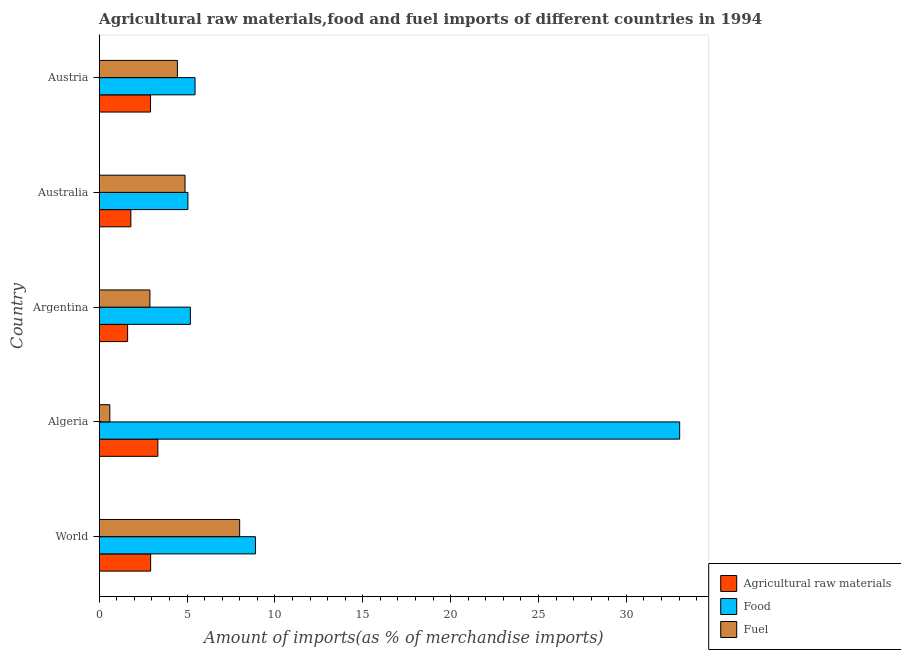How many different coloured bars are there?
Ensure brevity in your answer.  3. Are the number of bars per tick equal to the number of legend labels?
Provide a short and direct response. Yes. Are the number of bars on each tick of the Y-axis equal?
Make the answer very short. Yes. How many bars are there on the 2nd tick from the top?
Your response must be concise. 3. What is the percentage of fuel imports in Austria?
Your answer should be very brief. 4.45. Across all countries, what is the maximum percentage of food imports?
Give a very brief answer. 33.04. Across all countries, what is the minimum percentage of fuel imports?
Your answer should be very brief. 0.6. In which country was the percentage of raw materials imports maximum?
Offer a very short reply. Algeria. What is the total percentage of fuel imports in the graph?
Your answer should be very brief. 20.82. What is the difference between the percentage of raw materials imports in Algeria and that in Austria?
Offer a terse response. 0.42. What is the difference between the percentage of food imports in Argentina and the percentage of fuel imports in Australia?
Your answer should be compact. 0.31. What is the average percentage of fuel imports per country?
Make the answer very short. 4.16. What is the difference between the percentage of food imports and percentage of raw materials imports in Algeria?
Provide a succinct answer. 29.7. In how many countries, is the percentage of raw materials imports greater than 23 %?
Your answer should be compact. 0. What is the ratio of the percentage of food imports in Algeria to that in Austria?
Your response must be concise. 6.06. Is the percentage of raw materials imports in Australia less than that in World?
Provide a succinct answer. Yes. What is the difference between the highest and the second highest percentage of raw materials imports?
Ensure brevity in your answer.  0.41. What is the difference between the highest and the lowest percentage of fuel imports?
Your answer should be very brief. 7.39. What does the 3rd bar from the top in Argentina represents?
Give a very brief answer. Agricultural raw materials. What does the 3rd bar from the bottom in Argentina represents?
Provide a succinct answer. Fuel. Is it the case that in every country, the sum of the percentage of raw materials imports and percentage of food imports is greater than the percentage of fuel imports?
Ensure brevity in your answer.  Yes. How many bars are there?
Offer a terse response. 15. How many countries are there in the graph?
Give a very brief answer. 5. What is the difference between two consecutive major ticks on the X-axis?
Give a very brief answer. 5. Does the graph contain grids?
Make the answer very short. No. What is the title of the graph?
Ensure brevity in your answer.  Agricultural raw materials,food and fuel imports of different countries in 1994. What is the label or title of the X-axis?
Provide a succinct answer. Amount of imports(as % of merchandise imports). What is the Amount of imports(as % of merchandise imports) of Agricultural raw materials in World?
Keep it short and to the point. 2.93. What is the Amount of imports(as % of merchandise imports) of Food in World?
Offer a terse response. 8.89. What is the Amount of imports(as % of merchandise imports) of Fuel in World?
Provide a succinct answer. 7.99. What is the Amount of imports(as % of merchandise imports) of Agricultural raw materials in Algeria?
Your answer should be compact. 3.34. What is the Amount of imports(as % of merchandise imports) of Food in Algeria?
Make the answer very short. 33.04. What is the Amount of imports(as % of merchandise imports) of Fuel in Algeria?
Make the answer very short. 0.6. What is the Amount of imports(as % of merchandise imports) of Agricultural raw materials in Argentina?
Keep it short and to the point. 1.62. What is the Amount of imports(as % of merchandise imports) of Food in Argentina?
Give a very brief answer. 5.19. What is the Amount of imports(as % of merchandise imports) in Fuel in Argentina?
Provide a succinct answer. 2.88. What is the Amount of imports(as % of merchandise imports) of Agricultural raw materials in Australia?
Make the answer very short. 1.8. What is the Amount of imports(as % of merchandise imports) of Food in Australia?
Offer a terse response. 5.05. What is the Amount of imports(as % of merchandise imports) of Fuel in Australia?
Offer a very short reply. 4.88. What is the Amount of imports(as % of merchandise imports) in Agricultural raw materials in Austria?
Your answer should be very brief. 2.92. What is the Amount of imports(as % of merchandise imports) of Food in Austria?
Make the answer very short. 5.45. What is the Amount of imports(as % of merchandise imports) in Fuel in Austria?
Provide a succinct answer. 4.45. Across all countries, what is the maximum Amount of imports(as % of merchandise imports) of Agricultural raw materials?
Offer a very short reply. 3.34. Across all countries, what is the maximum Amount of imports(as % of merchandise imports) in Food?
Your answer should be very brief. 33.04. Across all countries, what is the maximum Amount of imports(as % of merchandise imports) in Fuel?
Keep it short and to the point. 7.99. Across all countries, what is the minimum Amount of imports(as % of merchandise imports) of Agricultural raw materials?
Offer a very short reply. 1.62. Across all countries, what is the minimum Amount of imports(as % of merchandise imports) in Food?
Your answer should be very brief. 5.05. Across all countries, what is the minimum Amount of imports(as % of merchandise imports) of Fuel?
Ensure brevity in your answer.  0.6. What is the total Amount of imports(as % of merchandise imports) in Agricultural raw materials in the graph?
Ensure brevity in your answer.  12.6. What is the total Amount of imports(as % of merchandise imports) of Food in the graph?
Ensure brevity in your answer.  57.62. What is the total Amount of imports(as % of merchandise imports) in Fuel in the graph?
Your answer should be very brief. 20.82. What is the difference between the Amount of imports(as % of merchandise imports) of Agricultural raw materials in World and that in Algeria?
Provide a succinct answer. -0.41. What is the difference between the Amount of imports(as % of merchandise imports) in Food in World and that in Algeria?
Ensure brevity in your answer.  -24.14. What is the difference between the Amount of imports(as % of merchandise imports) of Fuel in World and that in Algeria?
Your response must be concise. 7.39. What is the difference between the Amount of imports(as % of merchandise imports) of Agricultural raw materials in World and that in Argentina?
Provide a succinct answer. 1.31. What is the difference between the Amount of imports(as % of merchandise imports) of Food in World and that in Argentina?
Your answer should be very brief. 3.7. What is the difference between the Amount of imports(as % of merchandise imports) of Fuel in World and that in Argentina?
Provide a short and direct response. 5.11. What is the difference between the Amount of imports(as % of merchandise imports) of Agricultural raw materials in World and that in Australia?
Your response must be concise. 1.13. What is the difference between the Amount of imports(as % of merchandise imports) of Food in World and that in Australia?
Give a very brief answer. 3.84. What is the difference between the Amount of imports(as % of merchandise imports) in Fuel in World and that in Australia?
Your response must be concise. 3.11. What is the difference between the Amount of imports(as % of merchandise imports) of Agricultural raw materials in World and that in Austria?
Provide a succinct answer. 0.01. What is the difference between the Amount of imports(as % of merchandise imports) in Food in World and that in Austria?
Your answer should be very brief. 3.44. What is the difference between the Amount of imports(as % of merchandise imports) in Fuel in World and that in Austria?
Offer a terse response. 3.54. What is the difference between the Amount of imports(as % of merchandise imports) of Agricultural raw materials in Algeria and that in Argentina?
Offer a very short reply. 1.72. What is the difference between the Amount of imports(as % of merchandise imports) in Food in Algeria and that in Argentina?
Provide a short and direct response. 27.85. What is the difference between the Amount of imports(as % of merchandise imports) in Fuel in Algeria and that in Argentina?
Offer a terse response. -2.28. What is the difference between the Amount of imports(as % of merchandise imports) in Agricultural raw materials in Algeria and that in Australia?
Your answer should be very brief. 1.54. What is the difference between the Amount of imports(as % of merchandise imports) in Food in Algeria and that in Australia?
Give a very brief answer. 27.99. What is the difference between the Amount of imports(as % of merchandise imports) in Fuel in Algeria and that in Australia?
Your answer should be very brief. -4.28. What is the difference between the Amount of imports(as % of merchandise imports) of Agricultural raw materials in Algeria and that in Austria?
Provide a short and direct response. 0.42. What is the difference between the Amount of imports(as % of merchandise imports) of Food in Algeria and that in Austria?
Keep it short and to the point. 27.58. What is the difference between the Amount of imports(as % of merchandise imports) of Fuel in Algeria and that in Austria?
Your answer should be very brief. -3.85. What is the difference between the Amount of imports(as % of merchandise imports) in Agricultural raw materials in Argentina and that in Australia?
Offer a very short reply. -0.19. What is the difference between the Amount of imports(as % of merchandise imports) of Food in Argentina and that in Australia?
Provide a succinct answer. 0.14. What is the difference between the Amount of imports(as % of merchandise imports) of Fuel in Argentina and that in Australia?
Keep it short and to the point. -2. What is the difference between the Amount of imports(as % of merchandise imports) in Agricultural raw materials in Argentina and that in Austria?
Ensure brevity in your answer.  -1.3. What is the difference between the Amount of imports(as % of merchandise imports) of Food in Argentina and that in Austria?
Your response must be concise. -0.27. What is the difference between the Amount of imports(as % of merchandise imports) in Fuel in Argentina and that in Austria?
Your answer should be compact. -1.56. What is the difference between the Amount of imports(as % of merchandise imports) of Agricultural raw materials in Australia and that in Austria?
Make the answer very short. -1.12. What is the difference between the Amount of imports(as % of merchandise imports) in Food in Australia and that in Austria?
Provide a short and direct response. -0.41. What is the difference between the Amount of imports(as % of merchandise imports) of Fuel in Australia and that in Austria?
Your answer should be compact. 0.43. What is the difference between the Amount of imports(as % of merchandise imports) of Agricultural raw materials in World and the Amount of imports(as % of merchandise imports) of Food in Algeria?
Provide a succinct answer. -30.11. What is the difference between the Amount of imports(as % of merchandise imports) in Agricultural raw materials in World and the Amount of imports(as % of merchandise imports) in Fuel in Algeria?
Your response must be concise. 2.32. What is the difference between the Amount of imports(as % of merchandise imports) in Food in World and the Amount of imports(as % of merchandise imports) in Fuel in Algeria?
Offer a very short reply. 8.29. What is the difference between the Amount of imports(as % of merchandise imports) of Agricultural raw materials in World and the Amount of imports(as % of merchandise imports) of Food in Argentina?
Your response must be concise. -2.26. What is the difference between the Amount of imports(as % of merchandise imports) in Agricultural raw materials in World and the Amount of imports(as % of merchandise imports) in Fuel in Argentina?
Make the answer very short. 0.04. What is the difference between the Amount of imports(as % of merchandise imports) in Food in World and the Amount of imports(as % of merchandise imports) in Fuel in Argentina?
Give a very brief answer. 6.01. What is the difference between the Amount of imports(as % of merchandise imports) in Agricultural raw materials in World and the Amount of imports(as % of merchandise imports) in Food in Australia?
Keep it short and to the point. -2.12. What is the difference between the Amount of imports(as % of merchandise imports) in Agricultural raw materials in World and the Amount of imports(as % of merchandise imports) in Fuel in Australia?
Offer a very short reply. -1.96. What is the difference between the Amount of imports(as % of merchandise imports) in Food in World and the Amount of imports(as % of merchandise imports) in Fuel in Australia?
Give a very brief answer. 4.01. What is the difference between the Amount of imports(as % of merchandise imports) in Agricultural raw materials in World and the Amount of imports(as % of merchandise imports) in Food in Austria?
Provide a short and direct response. -2.53. What is the difference between the Amount of imports(as % of merchandise imports) of Agricultural raw materials in World and the Amount of imports(as % of merchandise imports) of Fuel in Austria?
Provide a succinct answer. -1.52. What is the difference between the Amount of imports(as % of merchandise imports) of Food in World and the Amount of imports(as % of merchandise imports) of Fuel in Austria?
Provide a short and direct response. 4.44. What is the difference between the Amount of imports(as % of merchandise imports) in Agricultural raw materials in Algeria and the Amount of imports(as % of merchandise imports) in Food in Argentina?
Your response must be concise. -1.85. What is the difference between the Amount of imports(as % of merchandise imports) in Agricultural raw materials in Algeria and the Amount of imports(as % of merchandise imports) in Fuel in Argentina?
Make the answer very short. 0.45. What is the difference between the Amount of imports(as % of merchandise imports) in Food in Algeria and the Amount of imports(as % of merchandise imports) in Fuel in Argentina?
Provide a short and direct response. 30.15. What is the difference between the Amount of imports(as % of merchandise imports) of Agricultural raw materials in Algeria and the Amount of imports(as % of merchandise imports) of Food in Australia?
Your response must be concise. -1.71. What is the difference between the Amount of imports(as % of merchandise imports) in Agricultural raw materials in Algeria and the Amount of imports(as % of merchandise imports) in Fuel in Australia?
Your response must be concise. -1.55. What is the difference between the Amount of imports(as % of merchandise imports) in Food in Algeria and the Amount of imports(as % of merchandise imports) in Fuel in Australia?
Your answer should be very brief. 28.15. What is the difference between the Amount of imports(as % of merchandise imports) in Agricultural raw materials in Algeria and the Amount of imports(as % of merchandise imports) in Food in Austria?
Keep it short and to the point. -2.12. What is the difference between the Amount of imports(as % of merchandise imports) of Agricultural raw materials in Algeria and the Amount of imports(as % of merchandise imports) of Fuel in Austria?
Make the answer very short. -1.11. What is the difference between the Amount of imports(as % of merchandise imports) of Food in Algeria and the Amount of imports(as % of merchandise imports) of Fuel in Austria?
Your answer should be very brief. 28.59. What is the difference between the Amount of imports(as % of merchandise imports) in Agricultural raw materials in Argentina and the Amount of imports(as % of merchandise imports) in Food in Australia?
Provide a short and direct response. -3.43. What is the difference between the Amount of imports(as % of merchandise imports) of Agricultural raw materials in Argentina and the Amount of imports(as % of merchandise imports) of Fuel in Australia?
Your answer should be compact. -3.27. What is the difference between the Amount of imports(as % of merchandise imports) in Food in Argentina and the Amount of imports(as % of merchandise imports) in Fuel in Australia?
Keep it short and to the point. 0.31. What is the difference between the Amount of imports(as % of merchandise imports) of Agricultural raw materials in Argentina and the Amount of imports(as % of merchandise imports) of Food in Austria?
Ensure brevity in your answer.  -3.84. What is the difference between the Amount of imports(as % of merchandise imports) in Agricultural raw materials in Argentina and the Amount of imports(as % of merchandise imports) in Fuel in Austria?
Your answer should be very brief. -2.83. What is the difference between the Amount of imports(as % of merchandise imports) in Food in Argentina and the Amount of imports(as % of merchandise imports) in Fuel in Austria?
Provide a succinct answer. 0.74. What is the difference between the Amount of imports(as % of merchandise imports) of Agricultural raw materials in Australia and the Amount of imports(as % of merchandise imports) of Food in Austria?
Give a very brief answer. -3.65. What is the difference between the Amount of imports(as % of merchandise imports) in Agricultural raw materials in Australia and the Amount of imports(as % of merchandise imports) in Fuel in Austria?
Your response must be concise. -2.65. What is the difference between the Amount of imports(as % of merchandise imports) of Food in Australia and the Amount of imports(as % of merchandise imports) of Fuel in Austria?
Provide a short and direct response. 0.6. What is the average Amount of imports(as % of merchandise imports) in Agricultural raw materials per country?
Your answer should be very brief. 2.52. What is the average Amount of imports(as % of merchandise imports) of Food per country?
Provide a short and direct response. 11.52. What is the average Amount of imports(as % of merchandise imports) in Fuel per country?
Ensure brevity in your answer.  4.16. What is the difference between the Amount of imports(as % of merchandise imports) in Agricultural raw materials and Amount of imports(as % of merchandise imports) in Food in World?
Your response must be concise. -5.97. What is the difference between the Amount of imports(as % of merchandise imports) in Agricultural raw materials and Amount of imports(as % of merchandise imports) in Fuel in World?
Ensure brevity in your answer.  -5.07. What is the difference between the Amount of imports(as % of merchandise imports) in Food and Amount of imports(as % of merchandise imports) in Fuel in World?
Offer a very short reply. 0.9. What is the difference between the Amount of imports(as % of merchandise imports) of Agricultural raw materials and Amount of imports(as % of merchandise imports) of Food in Algeria?
Offer a very short reply. -29.7. What is the difference between the Amount of imports(as % of merchandise imports) in Agricultural raw materials and Amount of imports(as % of merchandise imports) in Fuel in Algeria?
Give a very brief answer. 2.73. What is the difference between the Amount of imports(as % of merchandise imports) of Food and Amount of imports(as % of merchandise imports) of Fuel in Algeria?
Ensure brevity in your answer.  32.43. What is the difference between the Amount of imports(as % of merchandise imports) of Agricultural raw materials and Amount of imports(as % of merchandise imports) of Food in Argentina?
Provide a short and direct response. -3.57. What is the difference between the Amount of imports(as % of merchandise imports) of Agricultural raw materials and Amount of imports(as % of merchandise imports) of Fuel in Argentina?
Provide a short and direct response. -1.27. What is the difference between the Amount of imports(as % of merchandise imports) in Food and Amount of imports(as % of merchandise imports) in Fuel in Argentina?
Give a very brief answer. 2.3. What is the difference between the Amount of imports(as % of merchandise imports) of Agricultural raw materials and Amount of imports(as % of merchandise imports) of Food in Australia?
Give a very brief answer. -3.25. What is the difference between the Amount of imports(as % of merchandise imports) in Agricultural raw materials and Amount of imports(as % of merchandise imports) in Fuel in Australia?
Provide a short and direct response. -3.08. What is the difference between the Amount of imports(as % of merchandise imports) of Food and Amount of imports(as % of merchandise imports) of Fuel in Australia?
Your response must be concise. 0.17. What is the difference between the Amount of imports(as % of merchandise imports) of Agricultural raw materials and Amount of imports(as % of merchandise imports) of Food in Austria?
Offer a terse response. -2.53. What is the difference between the Amount of imports(as % of merchandise imports) in Agricultural raw materials and Amount of imports(as % of merchandise imports) in Fuel in Austria?
Your answer should be compact. -1.53. What is the ratio of the Amount of imports(as % of merchandise imports) in Agricultural raw materials in World to that in Algeria?
Provide a succinct answer. 0.88. What is the ratio of the Amount of imports(as % of merchandise imports) of Food in World to that in Algeria?
Your answer should be very brief. 0.27. What is the ratio of the Amount of imports(as % of merchandise imports) of Fuel in World to that in Algeria?
Make the answer very short. 13.23. What is the ratio of the Amount of imports(as % of merchandise imports) of Agricultural raw materials in World to that in Argentina?
Your answer should be very brief. 1.81. What is the ratio of the Amount of imports(as % of merchandise imports) in Food in World to that in Argentina?
Keep it short and to the point. 1.71. What is the ratio of the Amount of imports(as % of merchandise imports) of Fuel in World to that in Argentina?
Your answer should be very brief. 2.77. What is the ratio of the Amount of imports(as % of merchandise imports) in Agricultural raw materials in World to that in Australia?
Provide a succinct answer. 1.62. What is the ratio of the Amount of imports(as % of merchandise imports) of Food in World to that in Australia?
Provide a succinct answer. 1.76. What is the ratio of the Amount of imports(as % of merchandise imports) of Fuel in World to that in Australia?
Make the answer very short. 1.64. What is the ratio of the Amount of imports(as % of merchandise imports) of Food in World to that in Austria?
Your response must be concise. 1.63. What is the ratio of the Amount of imports(as % of merchandise imports) in Fuel in World to that in Austria?
Provide a succinct answer. 1.8. What is the ratio of the Amount of imports(as % of merchandise imports) of Agricultural raw materials in Algeria to that in Argentina?
Offer a terse response. 2.07. What is the ratio of the Amount of imports(as % of merchandise imports) of Food in Algeria to that in Argentina?
Your answer should be very brief. 6.37. What is the ratio of the Amount of imports(as % of merchandise imports) in Fuel in Algeria to that in Argentina?
Keep it short and to the point. 0.21. What is the ratio of the Amount of imports(as % of merchandise imports) of Agricultural raw materials in Algeria to that in Australia?
Your answer should be compact. 1.85. What is the ratio of the Amount of imports(as % of merchandise imports) of Food in Algeria to that in Australia?
Offer a terse response. 6.54. What is the ratio of the Amount of imports(as % of merchandise imports) in Fuel in Algeria to that in Australia?
Provide a short and direct response. 0.12. What is the ratio of the Amount of imports(as % of merchandise imports) of Agricultural raw materials in Algeria to that in Austria?
Ensure brevity in your answer.  1.14. What is the ratio of the Amount of imports(as % of merchandise imports) in Food in Algeria to that in Austria?
Your response must be concise. 6.06. What is the ratio of the Amount of imports(as % of merchandise imports) in Fuel in Algeria to that in Austria?
Offer a terse response. 0.14. What is the ratio of the Amount of imports(as % of merchandise imports) in Agricultural raw materials in Argentina to that in Australia?
Your response must be concise. 0.9. What is the ratio of the Amount of imports(as % of merchandise imports) of Food in Argentina to that in Australia?
Offer a terse response. 1.03. What is the ratio of the Amount of imports(as % of merchandise imports) of Fuel in Argentina to that in Australia?
Your answer should be very brief. 0.59. What is the ratio of the Amount of imports(as % of merchandise imports) in Agricultural raw materials in Argentina to that in Austria?
Provide a short and direct response. 0.55. What is the ratio of the Amount of imports(as % of merchandise imports) of Food in Argentina to that in Austria?
Offer a terse response. 0.95. What is the ratio of the Amount of imports(as % of merchandise imports) of Fuel in Argentina to that in Austria?
Your answer should be compact. 0.65. What is the ratio of the Amount of imports(as % of merchandise imports) in Agricultural raw materials in Australia to that in Austria?
Ensure brevity in your answer.  0.62. What is the ratio of the Amount of imports(as % of merchandise imports) in Food in Australia to that in Austria?
Ensure brevity in your answer.  0.93. What is the ratio of the Amount of imports(as % of merchandise imports) of Fuel in Australia to that in Austria?
Provide a succinct answer. 1.1. What is the difference between the highest and the second highest Amount of imports(as % of merchandise imports) in Agricultural raw materials?
Provide a succinct answer. 0.41. What is the difference between the highest and the second highest Amount of imports(as % of merchandise imports) in Food?
Make the answer very short. 24.14. What is the difference between the highest and the second highest Amount of imports(as % of merchandise imports) of Fuel?
Your answer should be compact. 3.11. What is the difference between the highest and the lowest Amount of imports(as % of merchandise imports) in Agricultural raw materials?
Provide a short and direct response. 1.72. What is the difference between the highest and the lowest Amount of imports(as % of merchandise imports) in Food?
Keep it short and to the point. 27.99. What is the difference between the highest and the lowest Amount of imports(as % of merchandise imports) in Fuel?
Provide a short and direct response. 7.39. 